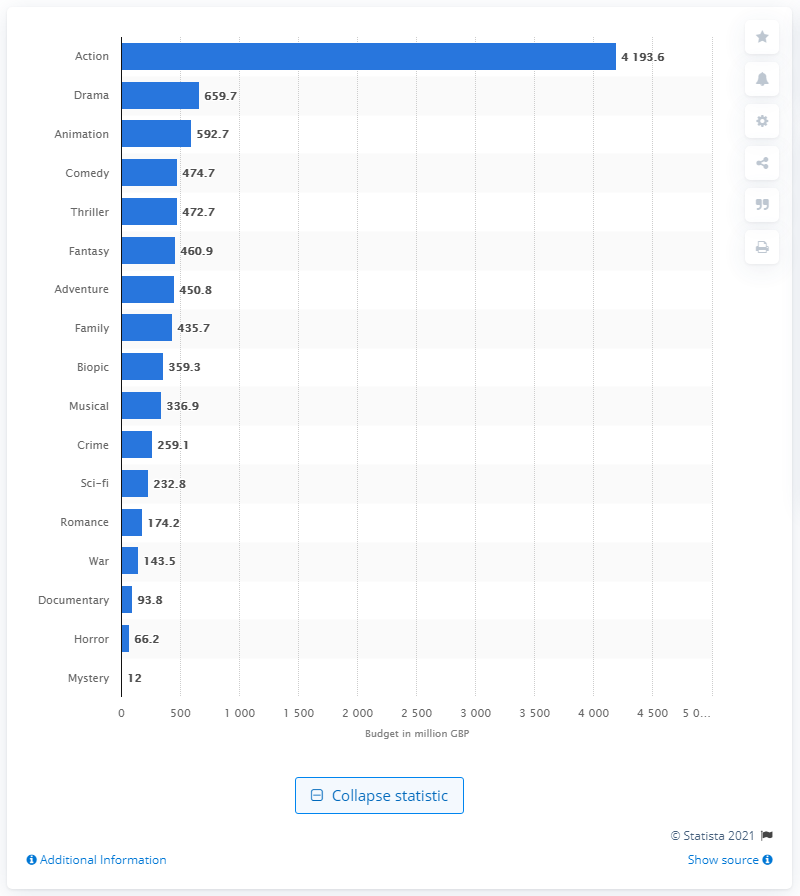Indicate a few pertinent items in this graphic. The amount of money spent on action movies between 2017 and 2019 is 4193.6 million dollars. 